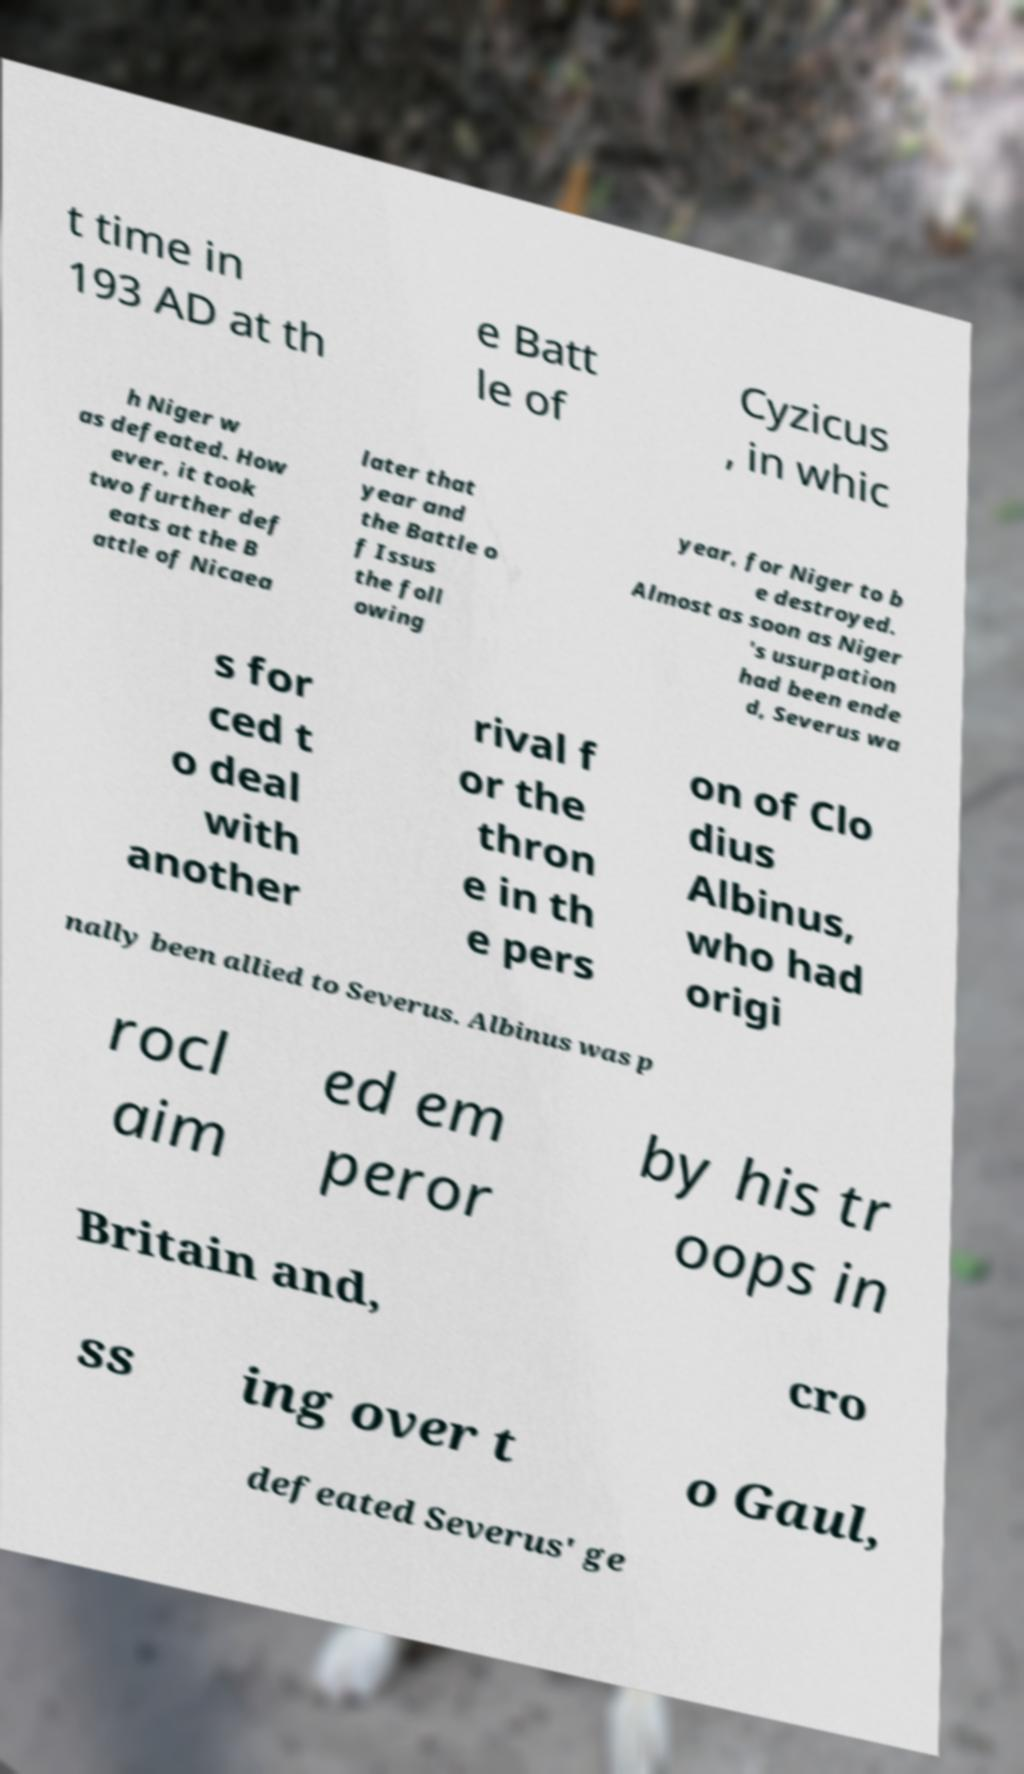Please read and relay the text visible in this image. What does it say? t time in 193 AD at th e Batt le of Cyzicus , in whic h Niger w as defeated. How ever, it took two further def eats at the B attle of Nicaea later that year and the Battle o f Issus the foll owing year, for Niger to b e destroyed. Almost as soon as Niger 's usurpation had been ende d, Severus wa s for ced t o deal with another rival f or the thron e in th e pers on of Clo dius Albinus, who had origi nally been allied to Severus. Albinus was p rocl aim ed em peror by his tr oops in Britain and, cro ss ing over t o Gaul, defeated Severus' ge 